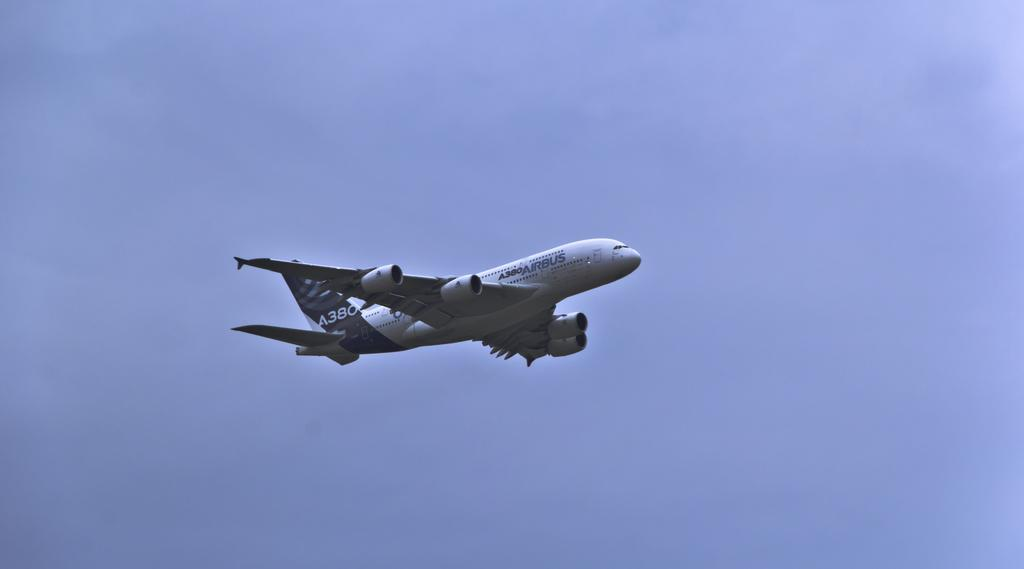What is the main subject of the image? The main subject of the image is an airplane. What is the airplane doing in the image? The airplane is flying in the air. What can be seen in the background of the image? The sky is visible in the background of the image. How many feet are visible on the airplane in the image? There are no feet visible on the airplane in the image, as airplanes do not have feet. 